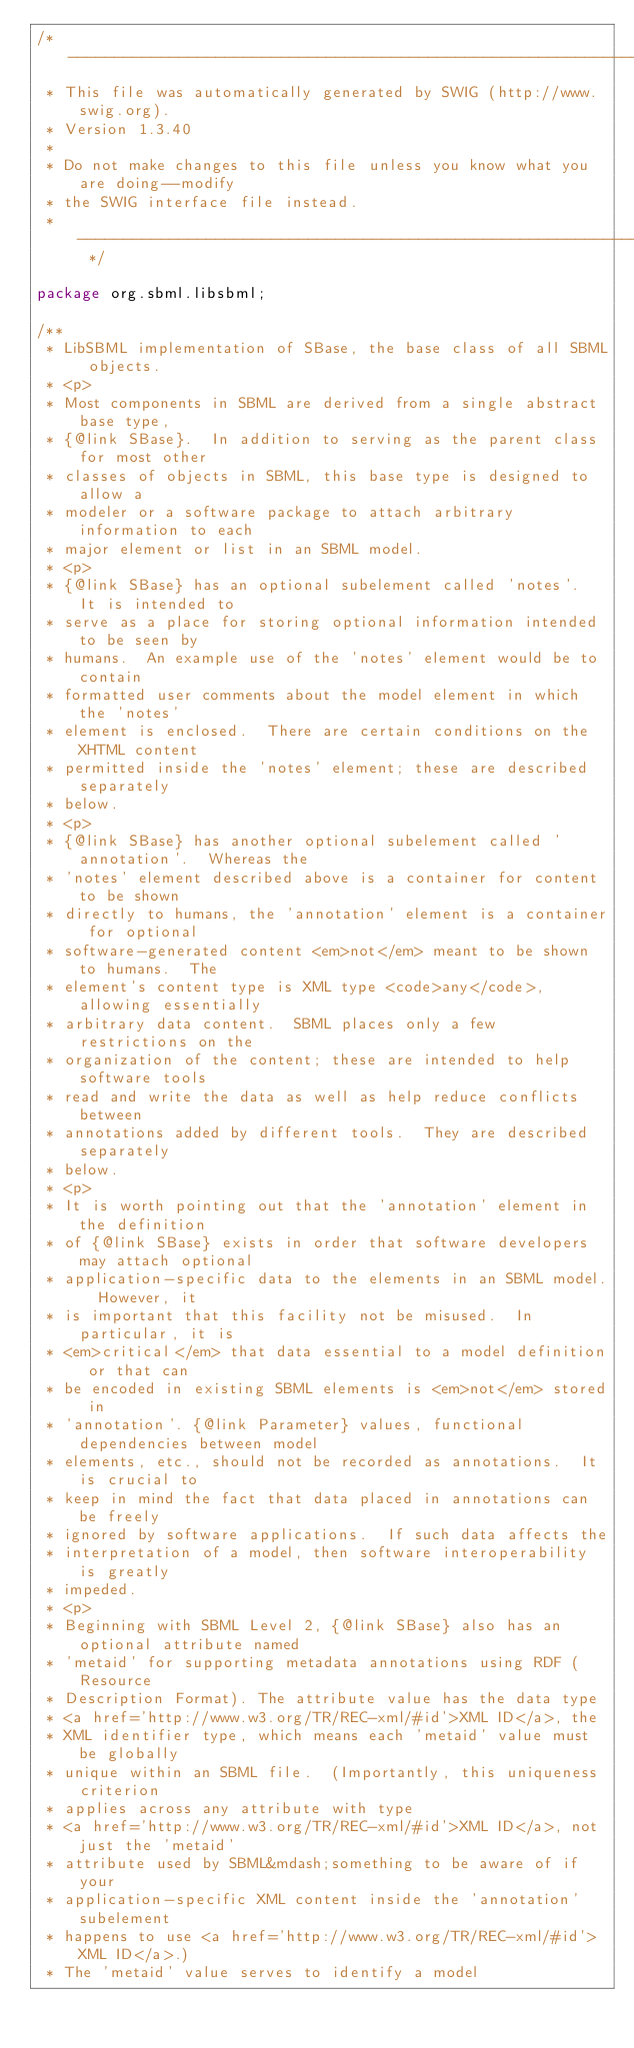<code> <loc_0><loc_0><loc_500><loc_500><_Java_>/* ----------------------------------------------------------------------------
 * This file was automatically generated by SWIG (http://www.swig.org).
 * Version 1.3.40
 *
 * Do not make changes to this file unless you know what you are doing--modify
 * the SWIG interface file instead.
 * ----------------------------------------------------------------------------- */

package org.sbml.libsbml;

/** 
 * LibSBML implementation of SBase, the base class of all SBML objects.
 * <p>
 * Most components in SBML are derived from a single abstract base type,
 * {@link SBase}.  In addition to serving as the parent class for most other
 * classes of objects in SBML, this base type is designed to allow a
 * modeler or a software package to attach arbitrary information to each
 * major element or list in an SBML model.
 * <p>
 * {@link SBase} has an optional subelement called 'notes'.  It is intended to
 * serve as a place for storing optional information intended to be seen by
 * humans.  An example use of the 'notes' element would be to contain
 * formatted user comments about the model element in which the 'notes'
 * element is enclosed.  There are certain conditions on the XHTML content
 * permitted inside the 'notes' element; these are described separately
 * below.
 * <p>
 * {@link SBase} has another optional subelement called 'annotation'.  Whereas the
 * 'notes' element described above is a container for content to be shown
 * directly to humans, the 'annotation' element is a container for optional
 * software-generated content <em>not</em> meant to be shown to humans.  The
 * element's content type is XML type <code>any</code>, allowing essentially
 * arbitrary data content.  SBML places only a few restrictions on the
 * organization of the content; these are intended to help software tools
 * read and write the data as well as help reduce conflicts between
 * annotations added by different tools.  They are described separately
 * below.
 * <p>
 * It is worth pointing out that the 'annotation' element in the definition
 * of {@link SBase} exists in order that software developers may attach optional
 * application-specific data to the elements in an SBML model.  However, it
 * is important that this facility not be misused.  In particular, it is
 * <em>critical</em> that data essential to a model definition or that can
 * be encoded in existing SBML elements is <em>not</em> stored in
 * 'annotation'. {@link Parameter} values, functional dependencies between model
 * elements, etc., should not be recorded as annotations.  It is crucial to
 * keep in mind the fact that data placed in annotations can be freely
 * ignored by software applications.  If such data affects the
 * interpretation of a model, then software interoperability is greatly
 * impeded.
 * <p>
 * Beginning with SBML Level 2, {@link SBase} also has an optional attribute named
 * 'metaid' for supporting metadata annotations using RDF (Resource
 * Description Format). The attribute value has the data type 
 * <a href='http://www.w3.org/TR/REC-xml/#id'>XML ID</a>, the
 * XML identifier type, which means each 'metaid' value must be globally
 * unique within an SBML file.  (Importantly, this uniqueness criterion
 * applies across any attribute with type 
 * <a href='http://www.w3.org/TR/REC-xml/#id'>XML ID</a>, not just the 'metaid'
 * attribute used by SBML&mdash;something to be aware of if your
 * application-specific XML content inside the 'annotation' subelement
 * happens to use <a href='http://www.w3.org/TR/REC-xml/#id'>XML ID</a>.)
 * The 'metaid' value serves to identify a model</code> 